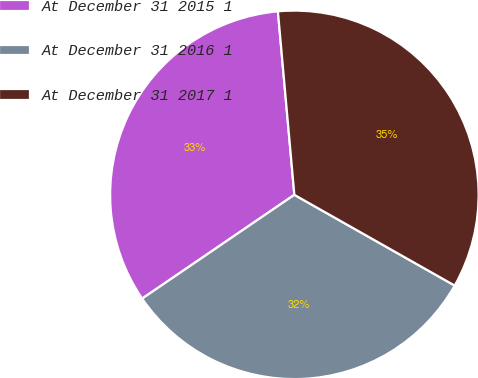Convert chart to OTSL. <chart><loc_0><loc_0><loc_500><loc_500><pie_chart><fcel>At December 31 2015 1<fcel>At December 31 2016 1<fcel>At December 31 2017 1<nl><fcel>33.1%<fcel>32.28%<fcel>34.62%<nl></chart> 